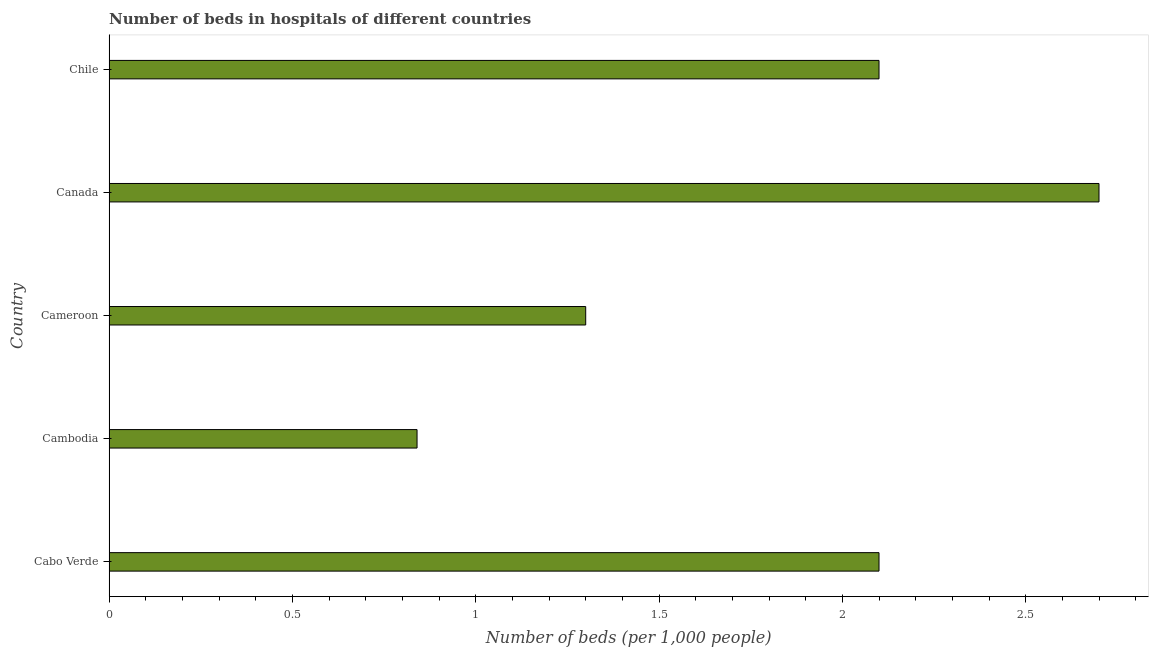Does the graph contain any zero values?
Offer a very short reply. No. What is the title of the graph?
Ensure brevity in your answer.  Number of beds in hospitals of different countries. What is the label or title of the X-axis?
Make the answer very short. Number of beds (per 1,0 people). What is the label or title of the Y-axis?
Ensure brevity in your answer.  Country. Across all countries, what is the minimum number of hospital beds?
Ensure brevity in your answer.  0.84. In which country was the number of hospital beds minimum?
Your response must be concise. Cambodia. What is the sum of the number of hospital beds?
Your response must be concise. 9.04. What is the average number of hospital beds per country?
Your answer should be very brief. 1.81. What is the median number of hospital beds?
Keep it short and to the point. 2.1. What is the ratio of the number of hospital beds in Cambodia to that in Chile?
Provide a short and direct response. 0.4. What is the difference between the highest and the second highest number of hospital beds?
Give a very brief answer. 0.6. What is the difference between the highest and the lowest number of hospital beds?
Provide a succinct answer. 1.86. How many bars are there?
Your response must be concise. 5. Are all the bars in the graph horizontal?
Provide a short and direct response. Yes. How many countries are there in the graph?
Ensure brevity in your answer.  5. Are the values on the major ticks of X-axis written in scientific E-notation?
Provide a short and direct response. No. What is the Number of beds (per 1,000 people) of Cabo Verde?
Your answer should be compact. 2.1. What is the Number of beds (per 1,000 people) of Cambodia?
Keep it short and to the point. 0.84. What is the Number of beds (per 1,000 people) in Canada?
Keep it short and to the point. 2.7. What is the difference between the Number of beds (per 1,000 people) in Cabo Verde and Cambodia?
Offer a very short reply. 1.26. What is the difference between the Number of beds (per 1,000 people) in Cabo Verde and Cameroon?
Ensure brevity in your answer.  0.8. What is the difference between the Number of beds (per 1,000 people) in Cambodia and Cameroon?
Provide a short and direct response. -0.46. What is the difference between the Number of beds (per 1,000 people) in Cambodia and Canada?
Ensure brevity in your answer.  -1.86. What is the difference between the Number of beds (per 1,000 people) in Cambodia and Chile?
Your response must be concise. -1.26. What is the difference between the Number of beds (per 1,000 people) in Cameroon and Canada?
Your response must be concise. -1.4. What is the difference between the Number of beds (per 1,000 people) in Cameroon and Chile?
Offer a terse response. -0.8. What is the ratio of the Number of beds (per 1,000 people) in Cabo Verde to that in Cameroon?
Your answer should be very brief. 1.61. What is the ratio of the Number of beds (per 1,000 people) in Cabo Verde to that in Canada?
Keep it short and to the point. 0.78. What is the ratio of the Number of beds (per 1,000 people) in Cabo Verde to that in Chile?
Ensure brevity in your answer.  1. What is the ratio of the Number of beds (per 1,000 people) in Cambodia to that in Cameroon?
Ensure brevity in your answer.  0.65. What is the ratio of the Number of beds (per 1,000 people) in Cambodia to that in Canada?
Ensure brevity in your answer.  0.31. What is the ratio of the Number of beds (per 1,000 people) in Cameroon to that in Canada?
Your answer should be compact. 0.48. What is the ratio of the Number of beds (per 1,000 people) in Cameroon to that in Chile?
Ensure brevity in your answer.  0.62. What is the ratio of the Number of beds (per 1,000 people) in Canada to that in Chile?
Offer a very short reply. 1.29. 